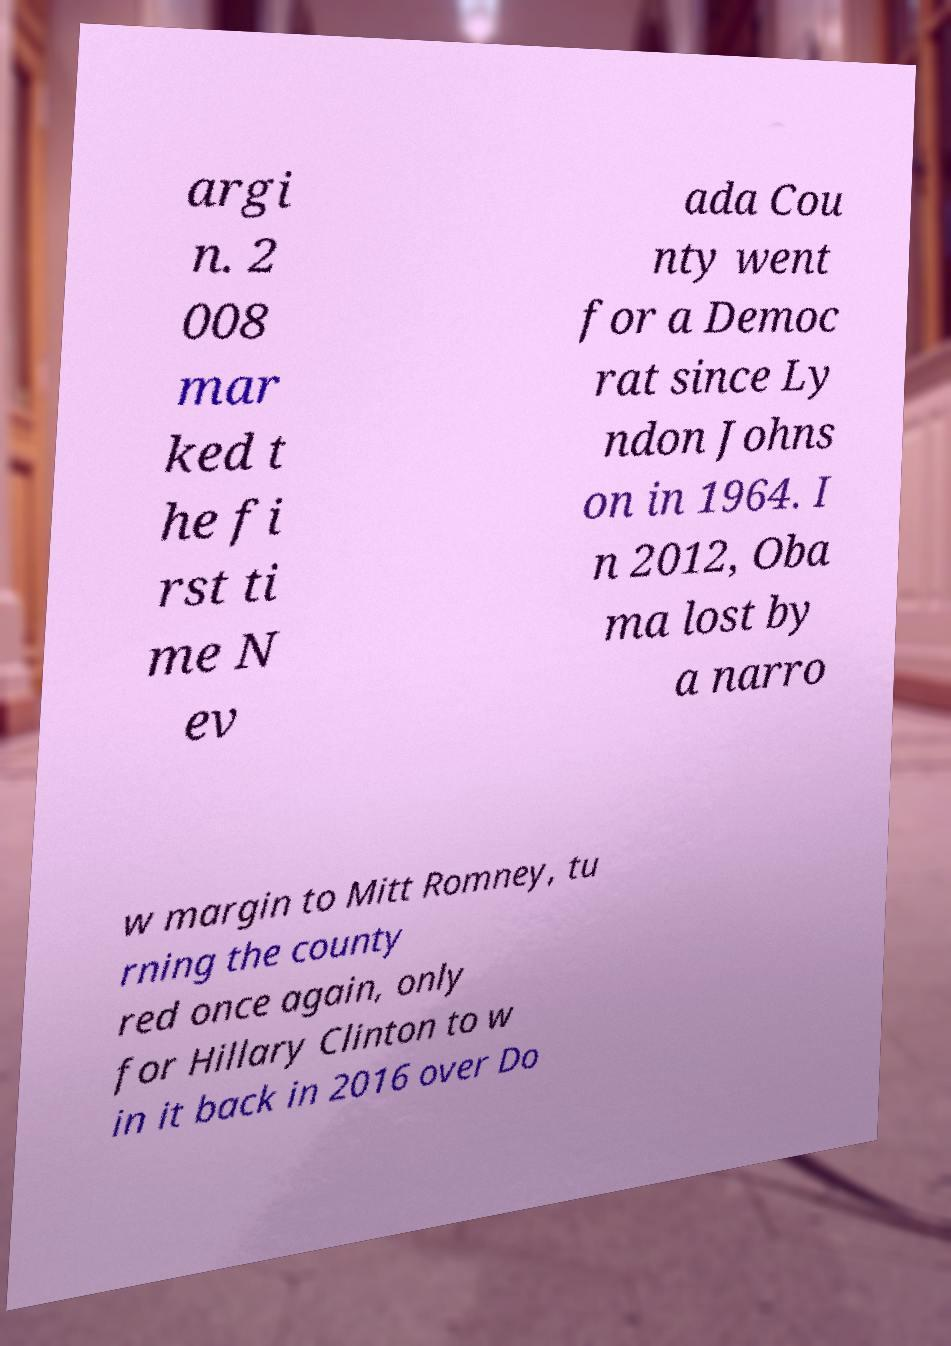What messages or text are displayed in this image? I need them in a readable, typed format. argi n. 2 008 mar ked t he fi rst ti me N ev ada Cou nty went for a Democ rat since Ly ndon Johns on in 1964. I n 2012, Oba ma lost by a narro w margin to Mitt Romney, tu rning the county red once again, only for Hillary Clinton to w in it back in 2016 over Do 